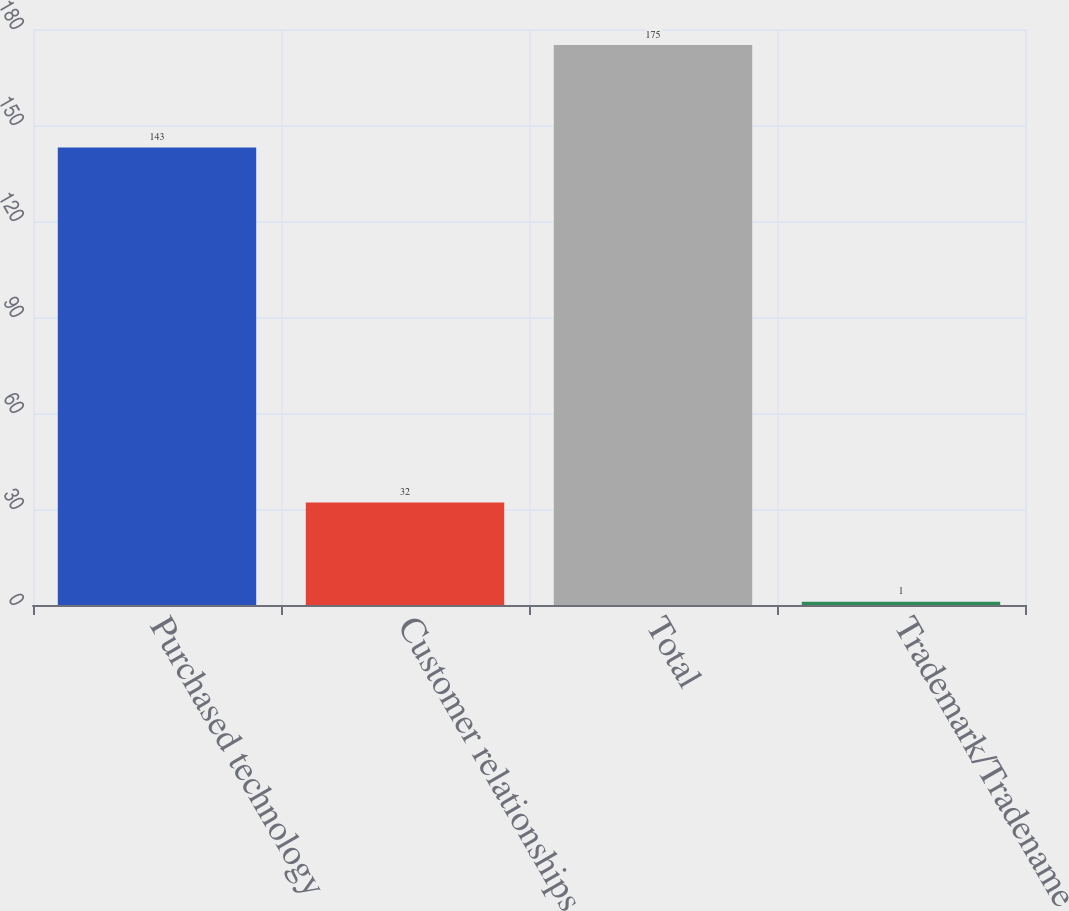Convert chart. <chart><loc_0><loc_0><loc_500><loc_500><bar_chart><fcel>Purchased technology<fcel>Customer relationships<fcel>Total<fcel>Trademark/Tradename<nl><fcel>143<fcel>32<fcel>175<fcel>1<nl></chart> 